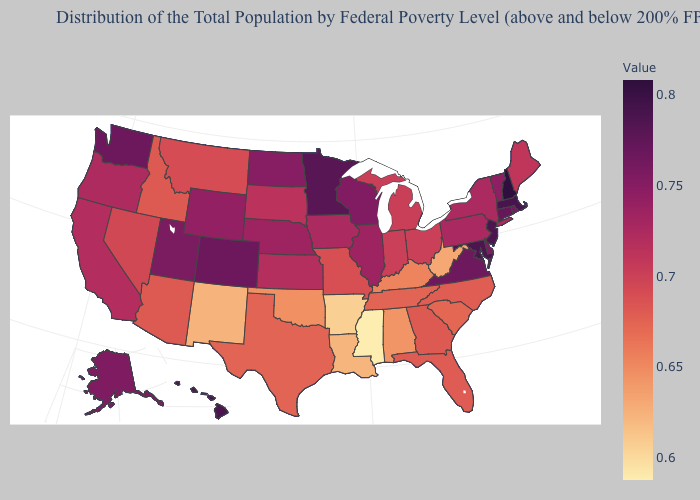Among the states that border Arizona , does Colorado have the lowest value?
Answer briefly. No. Among the states that border Alabama , which have the highest value?
Write a very short answer. Georgia. Is the legend a continuous bar?
Short answer required. Yes. Which states have the lowest value in the USA?
Quick response, please. Mississippi. Which states have the lowest value in the West?
Short answer required. New Mexico. 